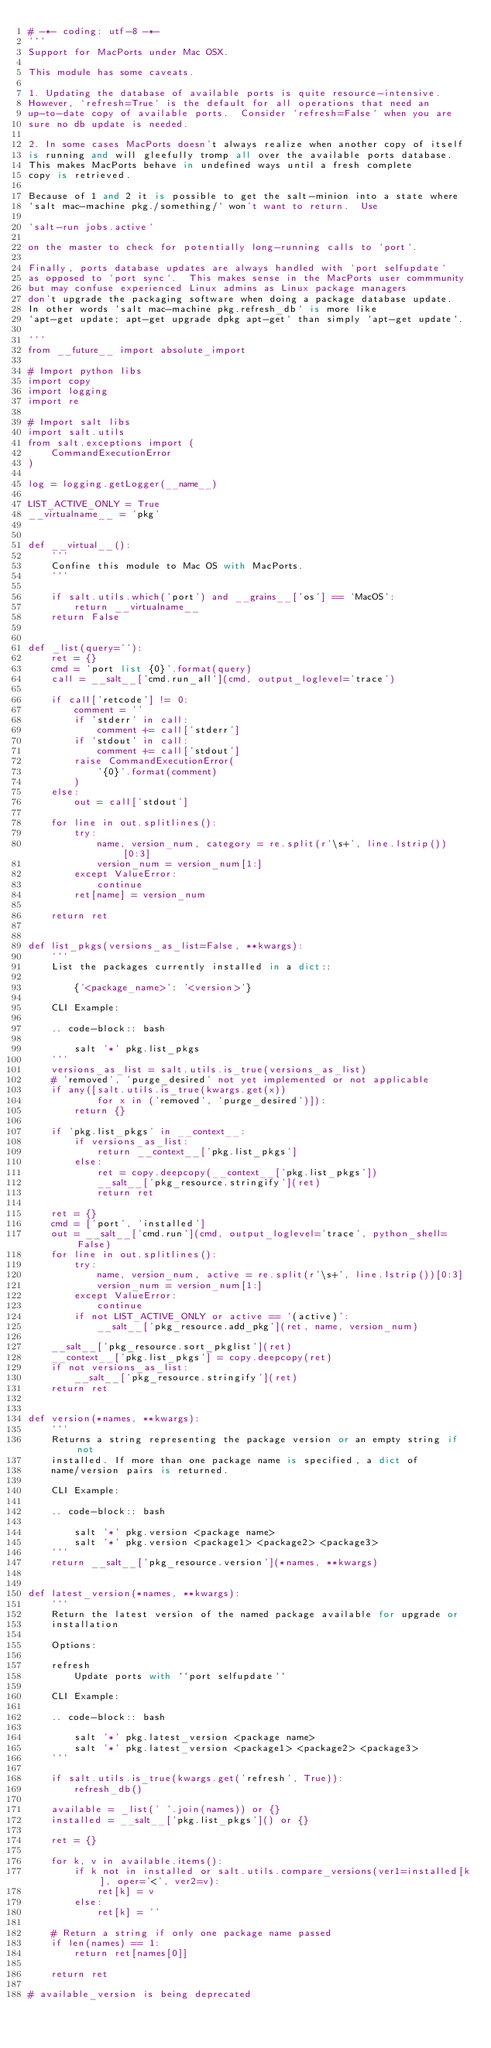Convert code to text. <code><loc_0><loc_0><loc_500><loc_500><_Python_># -*- coding: utf-8 -*-
'''
Support for MacPorts under Mac OSX.

This module has some caveats.

1. Updating the database of available ports is quite resource-intensive.
However, `refresh=True` is the default for all operations that need an
up-to-date copy of available ports.  Consider `refresh=False` when you are
sure no db update is needed.

2. In some cases MacPorts doesn't always realize when another copy of itself
is running and will gleefully tromp all over the available ports database.
This makes MacPorts behave in undefined ways until a fresh complete
copy is retrieved.

Because of 1 and 2 it is possible to get the salt-minion into a state where
`salt mac-machine pkg./something/` won't want to return.  Use

`salt-run jobs.active`

on the master to check for potentially long-running calls to `port`.

Finally, ports database updates are always handled with `port selfupdate`
as opposed to `port sync`.  This makes sense in the MacPorts user commmunity
but may confuse experienced Linux admins as Linux package managers
don't upgrade the packaging software when doing a package database update.
In other words `salt mac-machine pkg.refresh_db` is more like
`apt-get update; apt-get upgrade dpkg apt-get` than simply `apt-get update`.

'''
from __future__ import absolute_import

# Import python libs
import copy
import logging
import re

# Import salt libs
import salt.utils
from salt.exceptions import (
    CommandExecutionError
)

log = logging.getLogger(__name__)

LIST_ACTIVE_ONLY = True
__virtualname__ = 'pkg'


def __virtual__():
    '''
    Confine this module to Mac OS with MacPorts.
    '''

    if salt.utils.which('port') and __grains__['os'] == 'MacOS':
        return __virtualname__
    return False


def _list(query=''):
    ret = {}
    cmd = 'port list {0}'.format(query)
    call = __salt__['cmd.run_all'](cmd, output_loglevel='trace')

    if call['retcode'] != 0:
        comment = ''
        if 'stderr' in call:
            comment += call['stderr']
        if 'stdout' in call:
            comment += call['stdout']
        raise CommandExecutionError(
            '{0}'.format(comment)
        )
    else:
        out = call['stdout']

    for line in out.splitlines():
        try:
            name, version_num, category = re.split(r'\s+', line.lstrip())[0:3]
            version_num = version_num[1:]
        except ValueError:
            continue
        ret[name] = version_num

    return ret


def list_pkgs(versions_as_list=False, **kwargs):
    '''
    List the packages currently installed in a dict::

        {'<package_name>': '<version>'}

    CLI Example:

    .. code-block:: bash

        salt '*' pkg.list_pkgs
    '''
    versions_as_list = salt.utils.is_true(versions_as_list)
    # 'removed', 'purge_desired' not yet implemented or not applicable
    if any([salt.utils.is_true(kwargs.get(x))
            for x in ('removed', 'purge_desired')]):
        return {}

    if 'pkg.list_pkgs' in __context__:
        if versions_as_list:
            return __context__['pkg.list_pkgs']
        else:
            ret = copy.deepcopy(__context__['pkg.list_pkgs'])
            __salt__['pkg_resource.stringify'](ret)
            return ret

    ret = {}
    cmd = ['port', 'installed']
    out = __salt__['cmd.run'](cmd, output_loglevel='trace', python_shell=False)
    for line in out.splitlines():
        try:
            name, version_num, active = re.split(r'\s+', line.lstrip())[0:3]
            version_num = version_num[1:]
        except ValueError:
            continue
        if not LIST_ACTIVE_ONLY or active == '(active)':
            __salt__['pkg_resource.add_pkg'](ret, name, version_num)

    __salt__['pkg_resource.sort_pkglist'](ret)
    __context__['pkg.list_pkgs'] = copy.deepcopy(ret)
    if not versions_as_list:
        __salt__['pkg_resource.stringify'](ret)
    return ret


def version(*names, **kwargs):
    '''
    Returns a string representing the package version or an empty string if not
    installed. If more than one package name is specified, a dict of
    name/version pairs is returned.

    CLI Example:

    .. code-block:: bash

        salt '*' pkg.version <package name>
        salt '*' pkg.version <package1> <package2> <package3>
    '''
    return __salt__['pkg_resource.version'](*names, **kwargs)


def latest_version(*names, **kwargs):
    '''
    Return the latest version of the named package available for upgrade or
    installation

    Options:

    refresh
        Update ports with ``port selfupdate``

    CLI Example:

    .. code-block:: bash

        salt '*' pkg.latest_version <package name>
        salt '*' pkg.latest_version <package1> <package2> <package3>
    '''

    if salt.utils.is_true(kwargs.get('refresh', True)):
        refresh_db()

    available = _list(' '.join(names)) or {}
    installed = __salt__['pkg.list_pkgs']() or {}

    ret = {}

    for k, v in available.items():
        if k not in installed or salt.utils.compare_versions(ver1=installed[k], oper='<', ver2=v):
            ret[k] = v
        else:
            ret[k] = ''

    # Return a string if only one package name passed
    if len(names) == 1:
        return ret[names[0]]

    return ret

# available_version is being deprecated</code> 